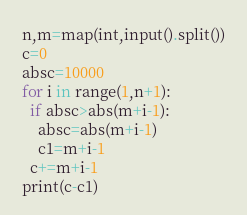Convert code to text. <code><loc_0><loc_0><loc_500><loc_500><_Python_>n,m=map(int,input().split())
c=0
absc=10000
for i in range(1,n+1):
  if absc>abs(m+i-1):
    absc=abs(m+i-1)
    c1=m+i-1
  c+=m+i-1
print(c-c1)</code> 